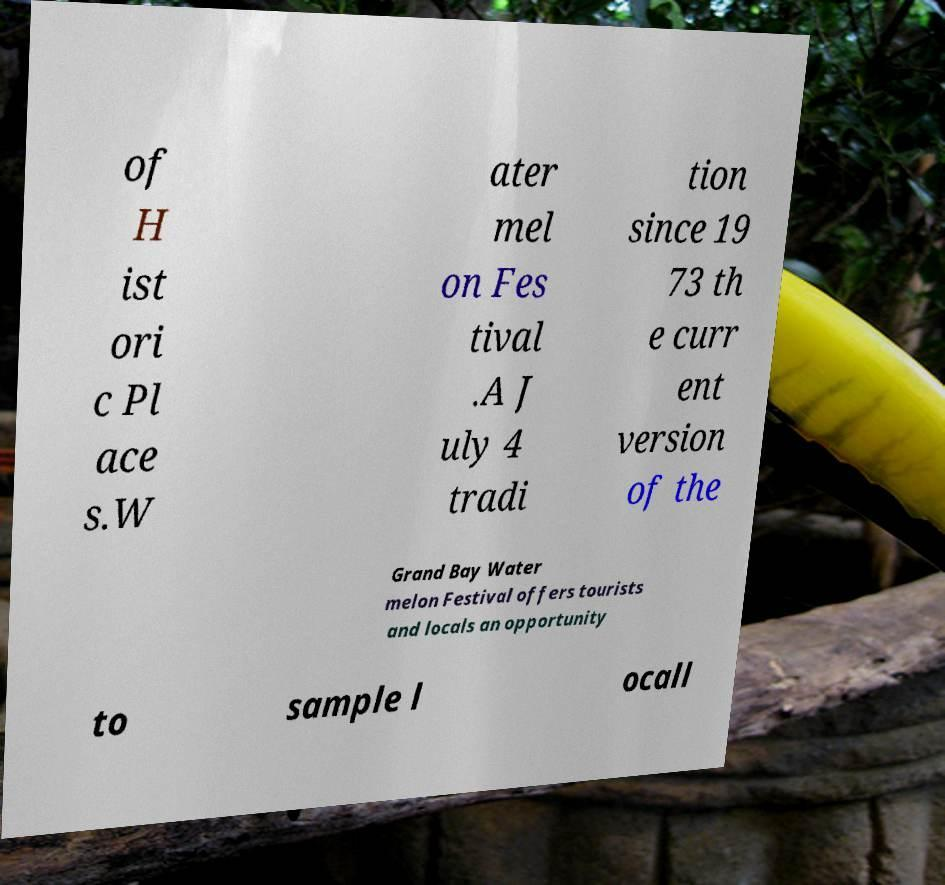There's text embedded in this image that I need extracted. Can you transcribe it verbatim? of H ist ori c Pl ace s.W ater mel on Fes tival .A J uly 4 tradi tion since 19 73 th e curr ent version of the Grand Bay Water melon Festival offers tourists and locals an opportunity to sample l ocall 